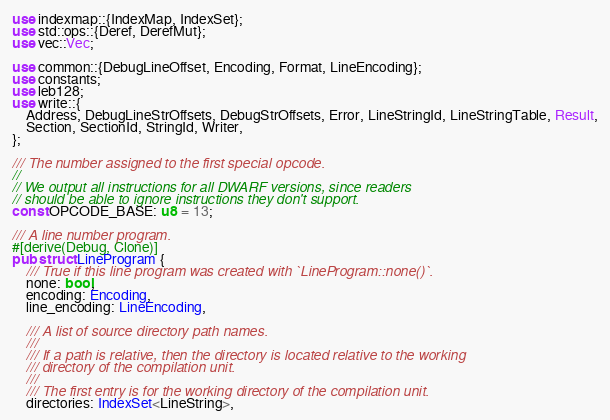<code> <loc_0><loc_0><loc_500><loc_500><_Rust_>use indexmap::{IndexMap, IndexSet};
use std::ops::{Deref, DerefMut};
use vec::Vec;

use common::{DebugLineOffset, Encoding, Format, LineEncoding};
use constants;
use leb128;
use write::{
    Address, DebugLineStrOffsets, DebugStrOffsets, Error, LineStringId, LineStringTable, Result,
    Section, SectionId, StringId, Writer,
};

/// The number assigned to the first special opcode.
//
// We output all instructions for all DWARF versions, since readers
// should be able to ignore instructions they don't support.
const OPCODE_BASE: u8 = 13;

/// A line number program.
#[derive(Debug, Clone)]
pub struct LineProgram {
    /// True if this line program was created with `LineProgram::none()`.
    none: bool,
    encoding: Encoding,
    line_encoding: LineEncoding,

    /// A list of source directory path names.
    ///
    /// If a path is relative, then the directory is located relative to the working
    /// directory of the compilation unit.
    ///
    /// The first entry is for the working directory of the compilation unit.
    directories: IndexSet<LineString>,
</code> 